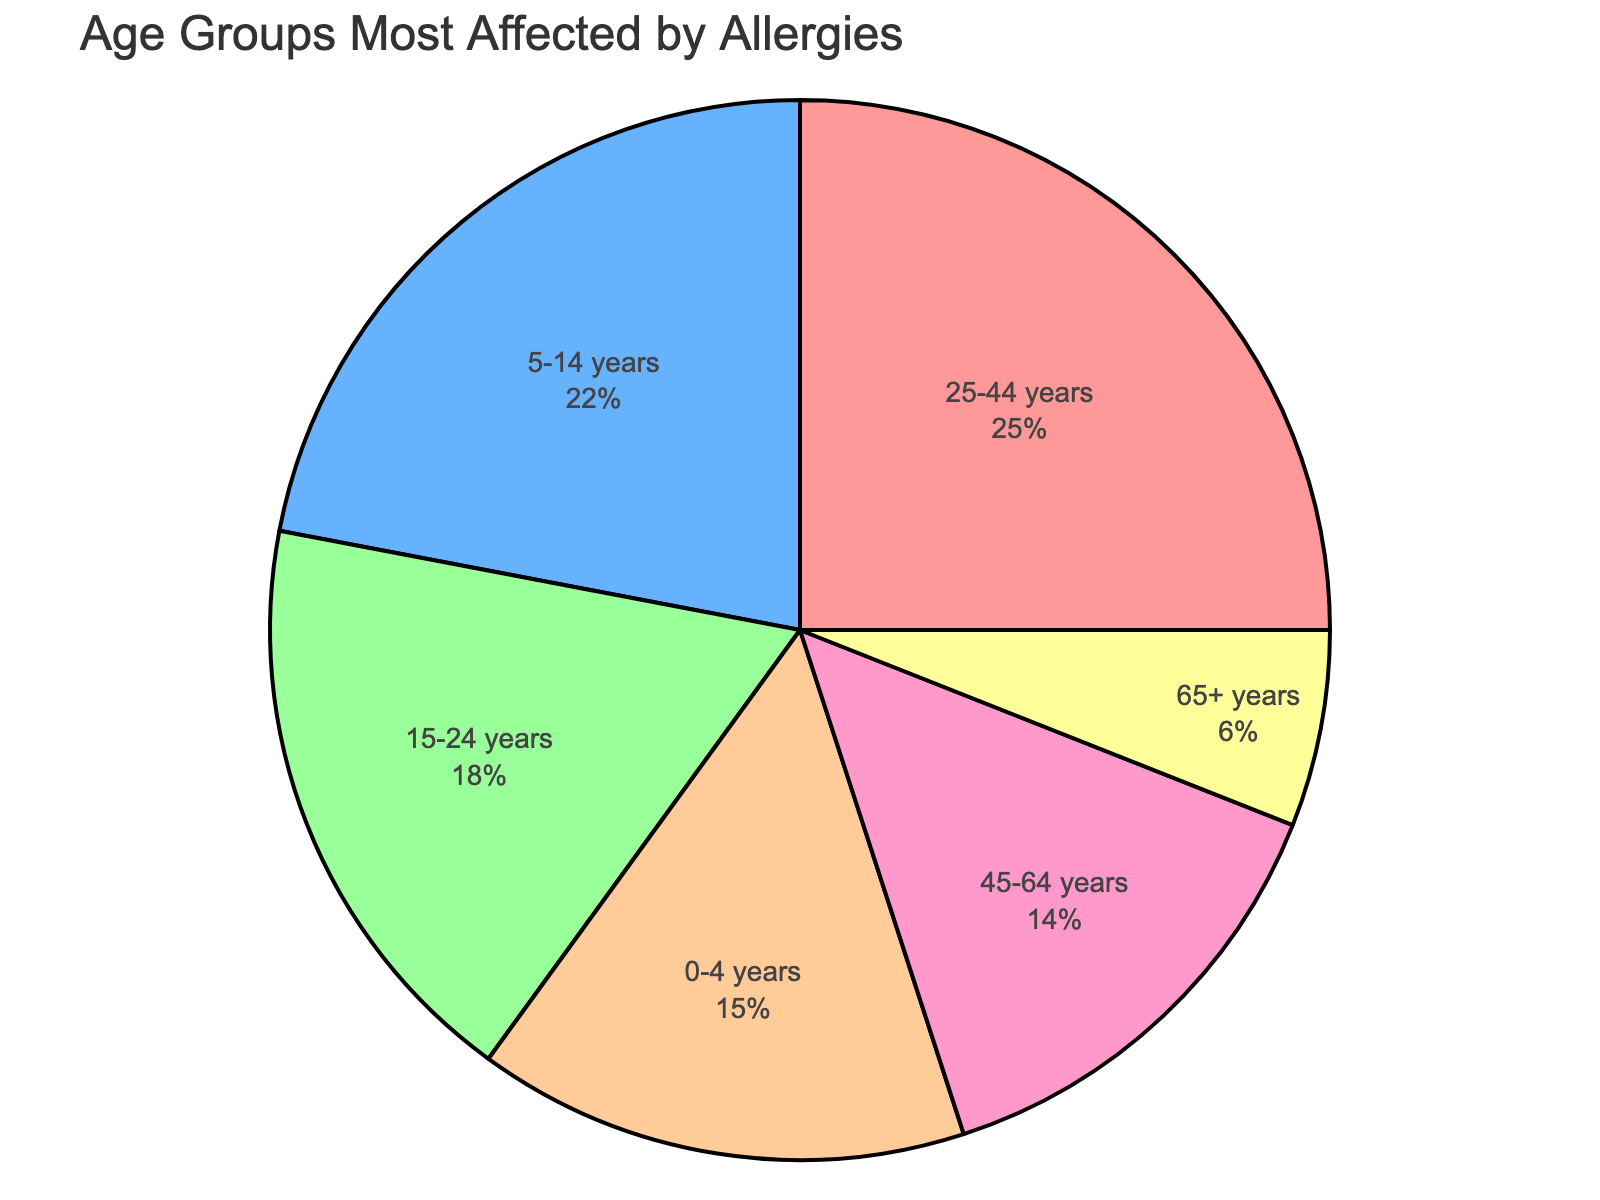What percentage of the age group 25-44 years is affected by allergies? From the pie chart, we can see that the percentage corresponding to the age group 25-44 years is indicated as 25%.
Answer: 25% Which age group has the second-highest percentage of individuals affected by allergies? By examining the chart, we see that the age group 5-14 years has the second-highest percentage, at 22%.
Answer: 5-14 years What is the combined percentage of individuals affected by allergies in the age groups 15-24 years and 45-64 years? According to the chart, the percentage for the age group 15-24 years is 18% and for the age group 45-64 years is 14%. Summing these up, we get 18 + 14 = 32%.
Answer: 32% How does the percentage of individuals affected by allergies in the 65+ years age group compare to those in the 0-4 years age group? The 65+ years age group has a 6% share, whereas the 0-4 years age group has a 15% share. Comparatively, 6% is less than 15%.
Answer: Less than Which age group has the least percentage of individuals affected by allergies, and what is that percentage? By inspecting the pie chart, the 65+ years age group has the least percentage, which is 6%.
Answer: 65+ years, 6% Is the percentage of individuals affected by allergies in the age group 25-44 years greater than the combined percentage of the age groups 0-4 years and 65+ years? The chart shows that 25-44 years is at 25%, whereas the combined percentage for 0-4 years (15%) and 65+ years (6%) is 21%. Since 25% is greater than 21%, the answer is yes.
Answer: Yes What color represents the 45-64 years age group, and what is its percentage? According to the chart description, the 45-64 years age group is represented by purple, and its from the segment, its percentage is indicated as 14%.
Answer: Purple, 14% What's the sum of percentages for the three age groups with the highest values? The age groups and their percentages are: 25-44 years (25%), 5-14 years (22%), and 15-24 years (18%). Summing these, we get 25 + 22 + 18 = 65%.
Answer: 65% How does the percentage of the 5-14 years age group compare with the 15-24 years age group? We can see from the chart that the 5-14 years age group has a percentage of 22%, while the 15-24 years age group has 18%. Thus, 22% is greater than 18%.
Answer: Greater than Which age groups have a percentage below 10%, and what are the percentages? From the chart, only the 65+ years age group has a percentage below 10%, which is 6%.
Answer: 65+ years, 6% 